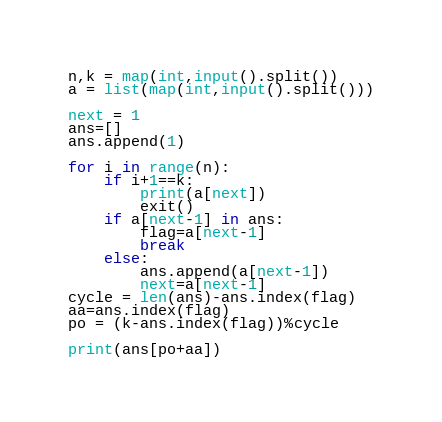<code> <loc_0><loc_0><loc_500><loc_500><_Python_>n,k = map(int,input().split())
a = list(map(int,input().split()))

next = 1
ans=[]
ans.append(1)

for i in range(n):
    if i+1==k:
        print(a[next])
        exit()
    if a[next-1] in ans:
        flag=a[next-1]
        break
    else:
        ans.append(a[next-1])
        next=a[next-1]
cycle = len(ans)-ans.index(flag)
aa=ans.index(flag)
po = (k-ans.index(flag))%cycle

print(ans[po+aa])


</code> 